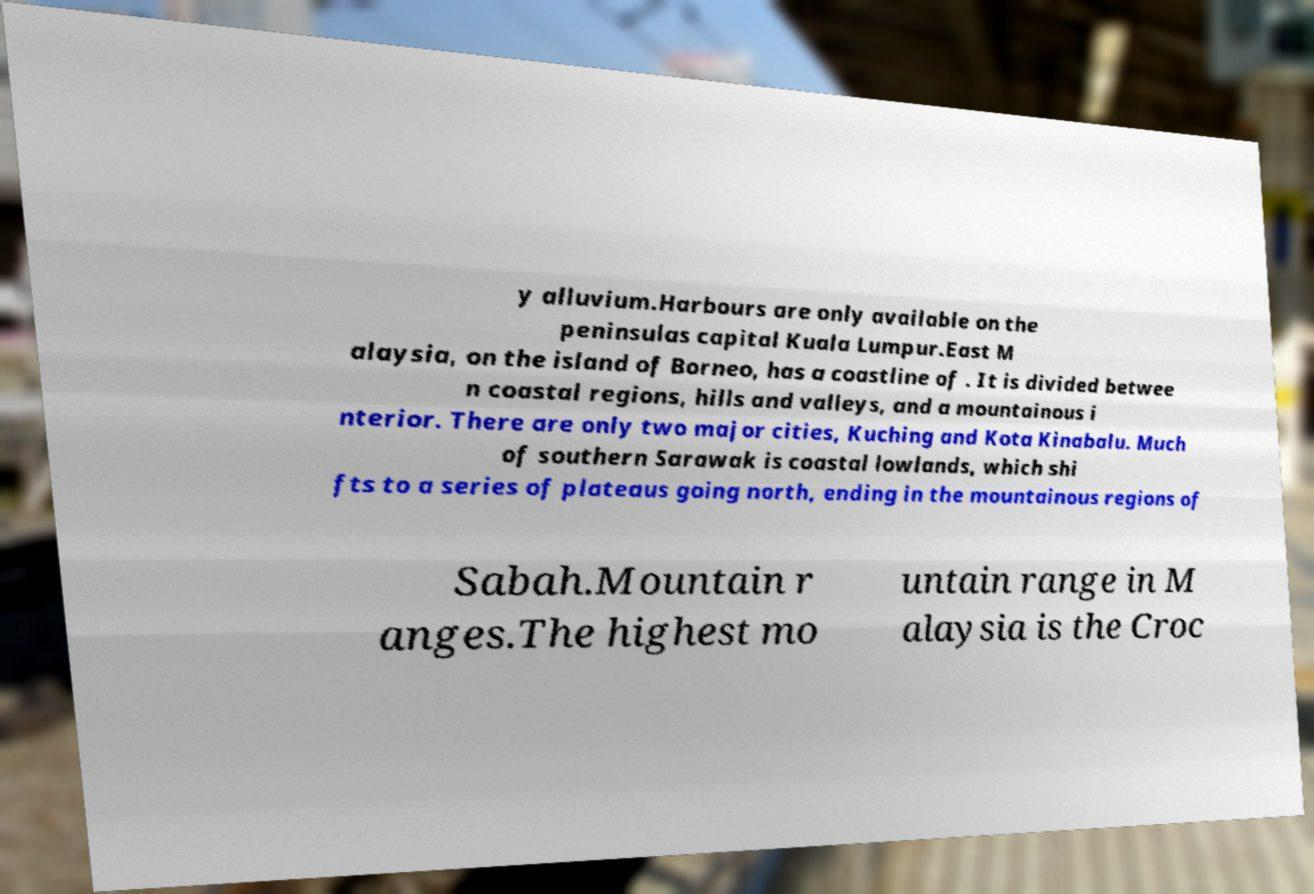There's text embedded in this image that I need extracted. Can you transcribe it verbatim? y alluvium.Harbours are only available on the peninsulas capital Kuala Lumpur.East M alaysia, on the island of Borneo, has a coastline of . It is divided betwee n coastal regions, hills and valleys, and a mountainous i nterior. There are only two major cities, Kuching and Kota Kinabalu. Much of southern Sarawak is coastal lowlands, which shi fts to a series of plateaus going north, ending in the mountainous regions of Sabah.Mountain r anges.The highest mo untain range in M alaysia is the Croc 